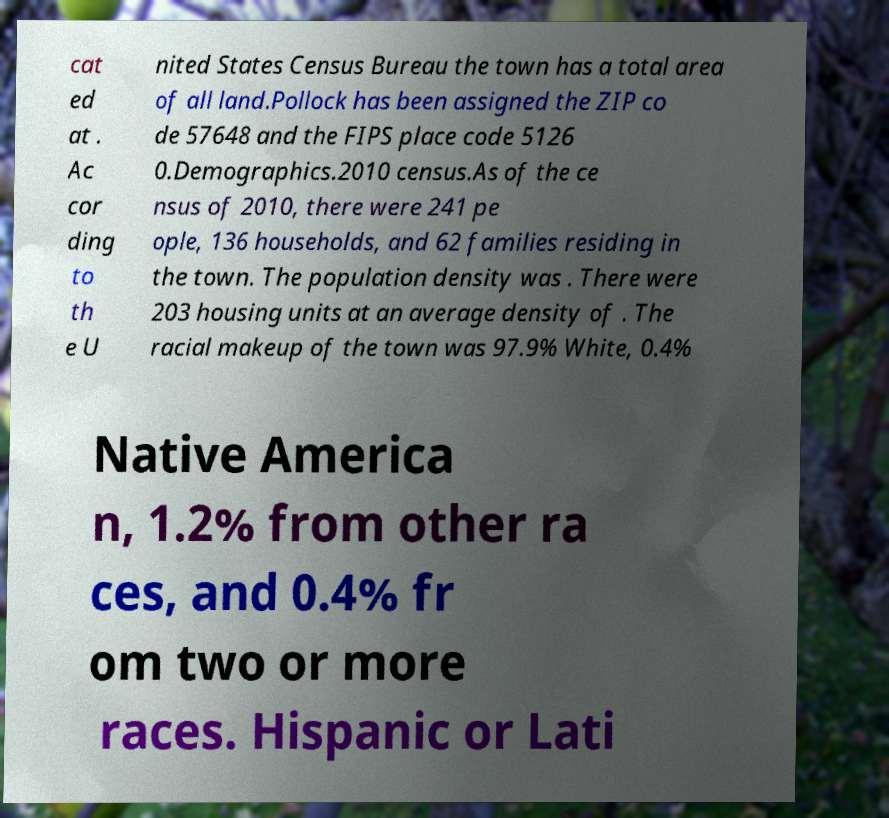I need the written content from this picture converted into text. Can you do that? cat ed at . Ac cor ding to th e U nited States Census Bureau the town has a total area of all land.Pollock has been assigned the ZIP co de 57648 and the FIPS place code 5126 0.Demographics.2010 census.As of the ce nsus of 2010, there were 241 pe ople, 136 households, and 62 families residing in the town. The population density was . There were 203 housing units at an average density of . The racial makeup of the town was 97.9% White, 0.4% Native America n, 1.2% from other ra ces, and 0.4% fr om two or more races. Hispanic or Lati 